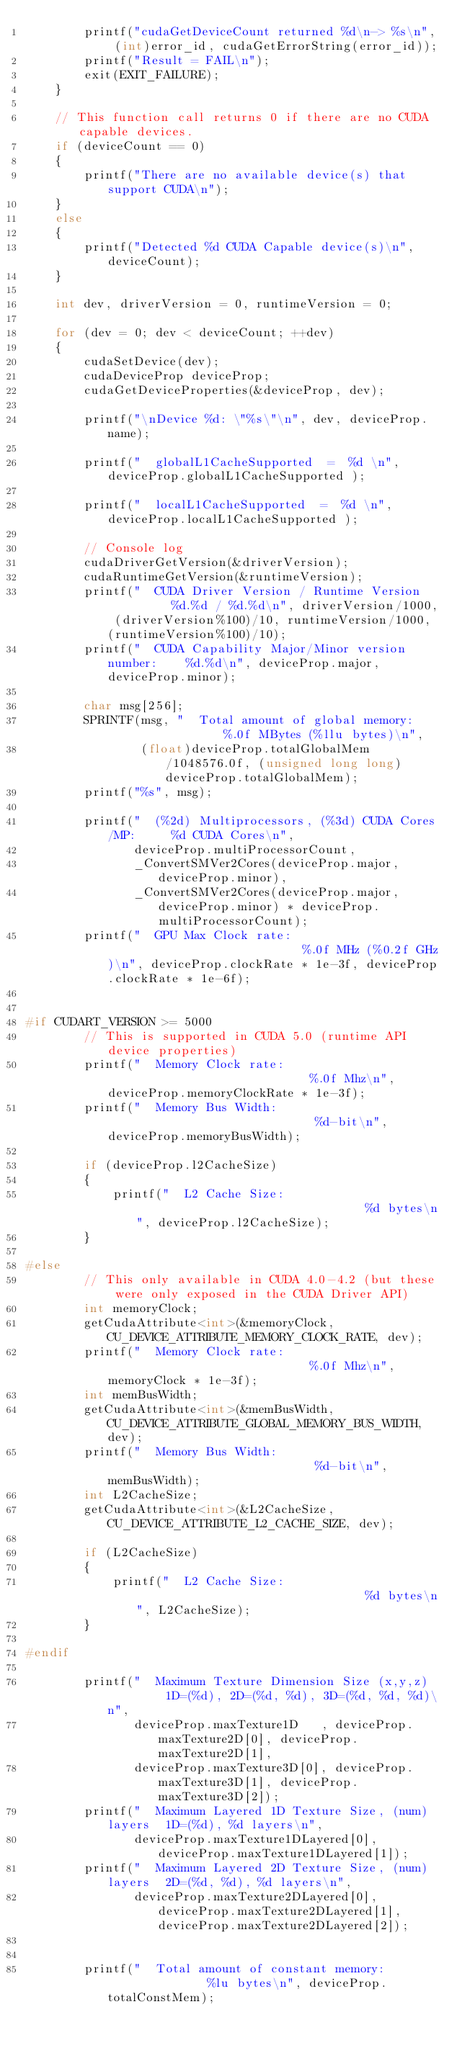Convert code to text. <code><loc_0><loc_0><loc_500><loc_500><_C++_>        printf("cudaGetDeviceCount returned %d\n-> %s\n", (int)error_id, cudaGetErrorString(error_id));
        printf("Result = FAIL\n");
        exit(EXIT_FAILURE);
    }

    // This function call returns 0 if there are no CUDA capable devices.
    if (deviceCount == 0)
    {
        printf("There are no available device(s) that support CUDA\n");
    }
    else
    {
        printf("Detected %d CUDA Capable device(s)\n", deviceCount);
    }

    int dev, driverVersion = 0, runtimeVersion = 0;

    for (dev = 0; dev < deviceCount; ++dev)
    {
        cudaSetDevice(dev);
        cudaDeviceProp deviceProp;
        cudaGetDeviceProperties(&deviceProp, dev);

        printf("\nDevice %d: \"%s\"\n", dev, deviceProp.name);

        printf("  globalL1CacheSupported  =  %d \n", deviceProp.globalL1CacheSupported );

        printf("  localL1CacheSupported  =  %d \n", deviceProp.localL1CacheSupported );

        // Console log
        cudaDriverGetVersion(&driverVersion);
        cudaRuntimeGetVersion(&runtimeVersion);
        printf("  CUDA Driver Version / Runtime Version          %d.%d / %d.%d\n", driverVersion/1000, (driverVersion%100)/10, runtimeVersion/1000, (runtimeVersion%100)/10);
        printf("  CUDA Capability Major/Minor version number:    %d.%d\n", deviceProp.major, deviceProp.minor);

        char msg[256];
        SPRINTF(msg, "  Total amount of global memory:                 %.0f MBytes (%llu bytes)\n",
                (float)deviceProp.totalGlobalMem/1048576.0f, (unsigned long long) deviceProp.totalGlobalMem);
        printf("%s", msg);

        printf("  (%2d) Multiprocessors, (%3d) CUDA Cores/MP:     %d CUDA Cores\n",
               deviceProp.multiProcessorCount,
               _ConvertSMVer2Cores(deviceProp.major, deviceProp.minor),
               _ConvertSMVer2Cores(deviceProp.major, deviceProp.minor) * deviceProp.multiProcessorCount);
        printf("  GPU Max Clock rate:                            %.0f MHz (%0.2f GHz)\n", deviceProp.clockRate * 1e-3f, deviceProp.clockRate * 1e-6f);


#if CUDART_VERSION >= 5000
        // This is supported in CUDA 5.0 (runtime API device properties)
        printf("  Memory Clock rate:                             %.0f Mhz\n", deviceProp.memoryClockRate * 1e-3f);
        printf("  Memory Bus Width:                              %d-bit\n",   deviceProp.memoryBusWidth);

        if (deviceProp.l2CacheSize)
        {
            printf("  L2 Cache Size:                                 %d bytes\n", deviceProp.l2CacheSize);
        }

#else
        // This only available in CUDA 4.0-4.2 (but these were only exposed in the CUDA Driver API)
        int memoryClock;
        getCudaAttribute<int>(&memoryClock, CU_DEVICE_ATTRIBUTE_MEMORY_CLOCK_RATE, dev);
        printf("  Memory Clock rate:                             %.0f Mhz\n", memoryClock * 1e-3f);
        int memBusWidth;
        getCudaAttribute<int>(&memBusWidth, CU_DEVICE_ATTRIBUTE_GLOBAL_MEMORY_BUS_WIDTH, dev);
        printf("  Memory Bus Width:                              %d-bit\n", memBusWidth);
        int L2CacheSize;
        getCudaAttribute<int>(&L2CacheSize, CU_DEVICE_ATTRIBUTE_L2_CACHE_SIZE, dev);

        if (L2CacheSize)
        {
            printf("  L2 Cache Size:                                 %d bytes\n", L2CacheSize);
        }

#endif

        printf("  Maximum Texture Dimension Size (x,y,z)         1D=(%d), 2D=(%d, %d), 3D=(%d, %d, %d)\n",
               deviceProp.maxTexture1D   , deviceProp.maxTexture2D[0], deviceProp.maxTexture2D[1],
               deviceProp.maxTexture3D[0], deviceProp.maxTexture3D[1], deviceProp.maxTexture3D[2]);
        printf("  Maximum Layered 1D Texture Size, (num) layers  1D=(%d), %d layers\n",
               deviceProp.maxTexture1DLayered[0], deviceProp.maxTexture1DLayered[1]);
        printf("  Maximum Layered 2D Texture Size, (num) layers  2D=(%d, %d), %d layers\n",
               deviceProp.maxTexture2DLayered[0], deviceProp.maxTexture2DLayered[1], deviceProp.maxTexture2DLayered[2]);


        printf("  Total amount of constant memory:               %lu bytes\n", deviceProp.totalConstMem);</code> 